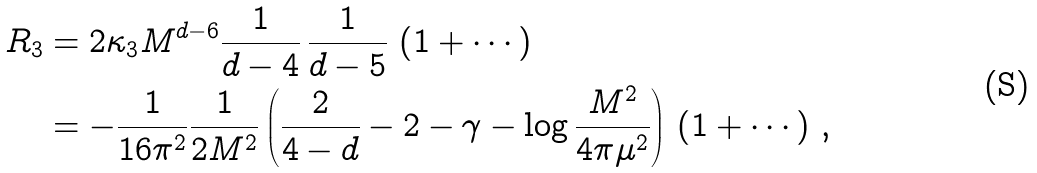Convert formula to latex. <formula><loc_0><loc_0><loc_500><loc_500>R _ { 3 } & = 2 \kappa _ { 3 } M ^ { d - 6 } \frac { 1 } { d - 4 } \, \frac { 1 } { d - 5 } \, \left ( 1 + \cdots \right ) \\ & = - \frac { 1 } { 1 6 \pi ^ { 2 } } \frac { 1 } { 2 M ^ { 2 } } \left ( \frac { 2 } { 4 - d } - 2 - \gamma - \log \frac { M ^ { 2 } } { 4 \pi \mu ^ { 2 } } \right ) \, \left ( 1 + \cdots \right ) \, ,</formula> 